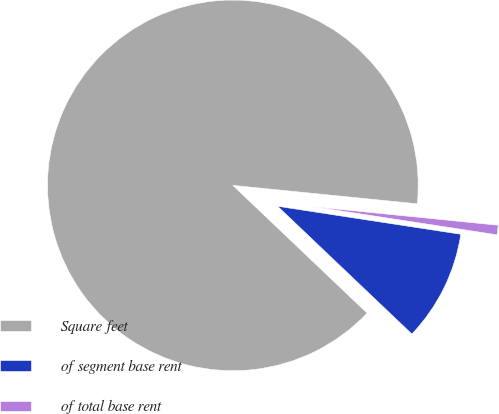Convert chart to OTSL. <chart><loc_0><loc_0><loc_500><loc_500><pie_chart><fcel>Square feet<fcel>of segment base rent<fcel>of total base rent<nl><fcel>89.48%<fcel>9.69%<fcel>0.83%<nl></chart> 